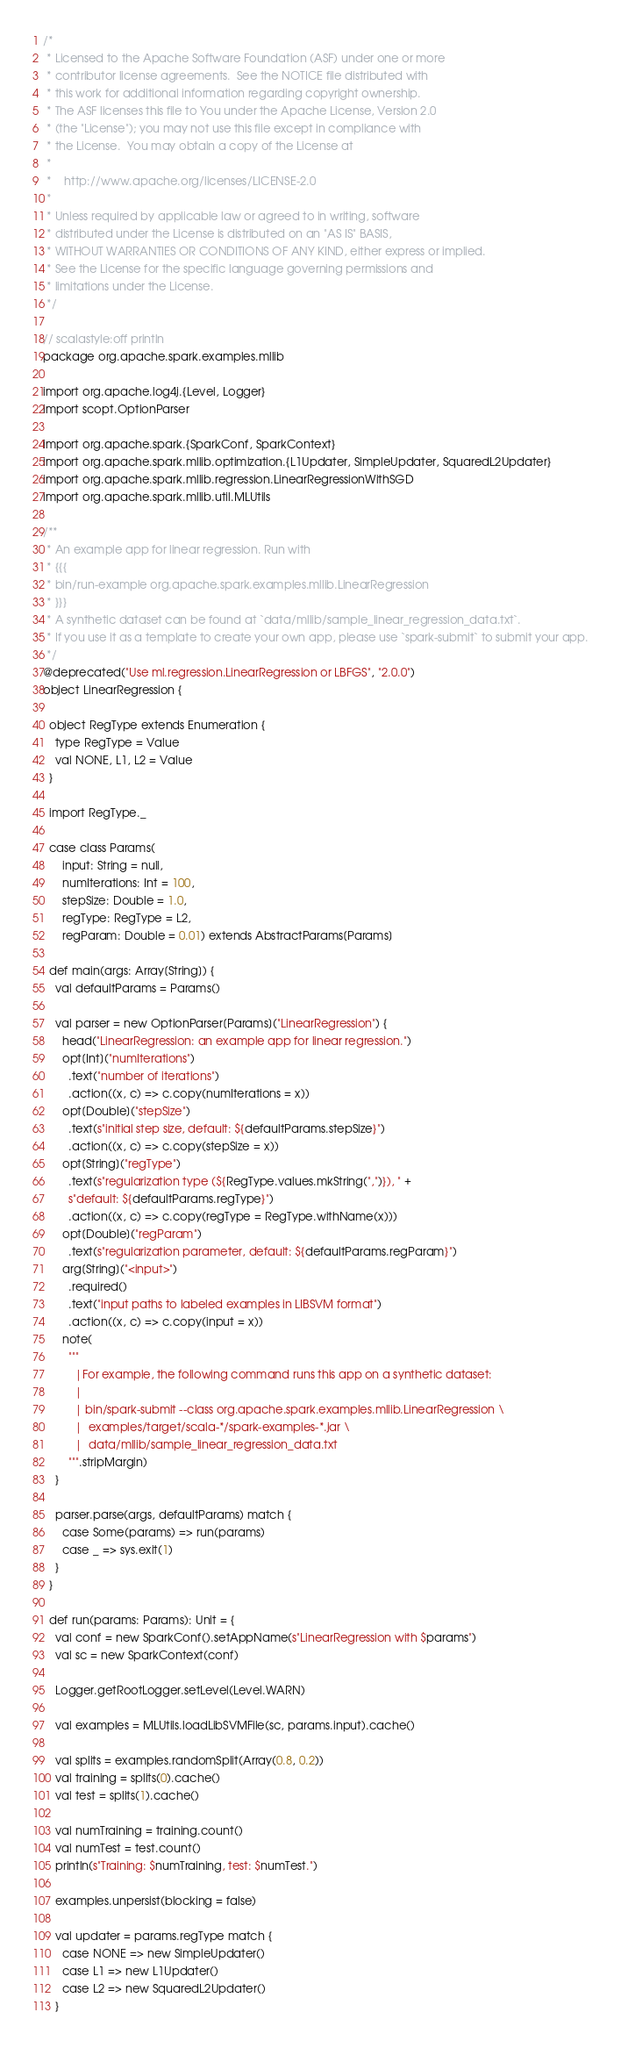Convert code to text. <code><loc_0><loc_0><loc_500><loc_500><_Scala_>/*
 * Licensed to the Apache Software Foundation (ASF) under one or more
 * contributor license agreements.  See the NOTICE file distributed with
 * this work for additional information regarding copyright ownership.
 * The ASF licenses this file to You under the Apache License, Version 2.0
 * (the "License"); you may not use this file except in compliance with
 * the License.  You may obtain a copy of the License at
 *
 *    http://www.apache.org/licenses/LICENSE-2.0
 *
 * Unless required by applicable law or agreed to in writing, software
 * distributed under the License is distributed on an "AS IS" BASIS,
 * WITHOUT WARRANTIES OR CONDITIONS OF ANY KIND, either express or implied.
 * See the License for the specific language governing permissions and
 * limitations under the License.
 */

// scalastyle:off println
package org.apache.spark.examples.mllib

import org.apache.log4j.{Level, Logger}
import scopt.OptionParser

import org.apache.spark.{SparkConf, SparkContext}
import org.apache.spark.mllib.optimization.{L1Updater, SimpleUpdater, SquaredL2Updater}
import org.apache.spark.mllib.regression.LinearRegressionWithSGD
import org.apache.spark.mllib.util.MLUtils

/**
 * An example app for linear regression. Run with
 * {{{
 * bin/run-example org.apache.spark.examples.mllib.LinearRegression
 * }}}
 * A synthetic dataset can be found at `data/mllib/sample_linear_regression_data.txt`.
 * If you use it as a template to create your own app, please use `spark-submit` to submit your app.
 */
@deprecated("Use ml.regression.LinearRegression or LBFGS", "2.0.0")
object LinearRegression {

  object RegType extends Enumeration {
    type RegType = Value
    val NONE, L1, L2 = Value
  }

  import RegType._

  case class Params(
      input: String = null,
      numIterations: Int = 100,
      stepSize: Double = 1.0,
      regType: RegType = L2,
      regParam: Double = 0.01) extends AbstractParams[Params]

  def main(args: Array[String]) {
    val defaultParams = Params()

    val parser = new OptionParser[Params]("LinearRegression") {
      head("LinearRegression: an example app for linear regression.")
      opt[Int]("numIterations")
        .text("number of iterations")
        .action((x, c) => c.copy(numIterations = x))
      opt[Double]("stepSize")
        .text(s"initial step size, default: ${defaultParams.stepSize}")
        .action((x, c) => c.copy(stepSize = x))
      opt[String]("regType")
        .text(s"regularization type (${RegType.values.mkString(",")}), " +
        s"default: ${defaultParams.regType}")
        .action((x, c) => c.copy(regType = RegType.withName(x)))
      opt[Double]("regParam")
        .text(s"regularization parameter, default: ${defaultParams.regParam}")
      arg[String]("<input>")
        .required()
        .text("input paths to labeled examples in LIBSVM format")
        .action((x, c) => c.copy(input = x))
      note(
        """
          |For example, the following command runs this app on a synthetic dataset:
          |
          | bin/spark-submit --class org.apache.spark.examples.mllib.LinearRegression \
          |  examples/target/scala-*/spark-examples-*.jar \
          |  data/mllib/sample_linear_regression_data.txt
        """.stripMargin)
    }

    parser.parse(args, defaultParams) match {
      case Some(params) => run(params)
      case _ => sys.exit(1)
    }
  }

  def run(params: Params): Unit = {
    val conf = new SparkConf().setAppName(s"LinearRegression with $params")
    val sc = new SparkContext(conf)

    Logger.getRootLogger.setLevel(Level.WARN)

    val examples = MLUtils.loadLibSVMFile(sc, params.input).cache()

    val splits = examples.randomSplit(Array(0.8, 0.2))
    val training = splits(0).cache()
    val test = splits(1).cache()

    val numTraining = training.count()
    val numTest = test.count()
    println(s"Training: $numTraining, test: $numTest.")

    examples.unpersist(blocking = false)

    val updater = params.regType match {
      case NONE => new SimpleUpdater()
      case L1 => new L1Updater()
      case L2 => new SquaredL2Updater()
    }
</code> 